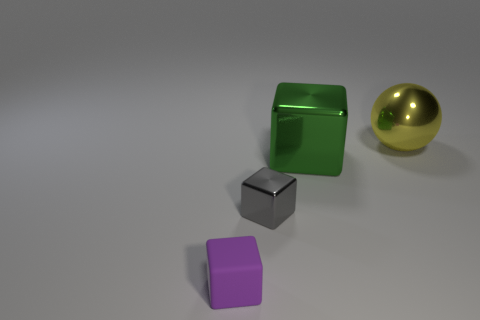Add 1 big red shiny objects. How many objects exist? 5 Subtract all balls. How many objects are left? 3 Subtract all small yellow shiny spheres. Subtract all tiny purple things. How many objects are left? 3 Add 4 tiny purple matte objects. How many tiny purple matte objects are left? 5 Add 2 small cyan rubber balls. How many small cyan rubber balls exist? 2 Subtract 1 green cubes. How many objects are left? 3 